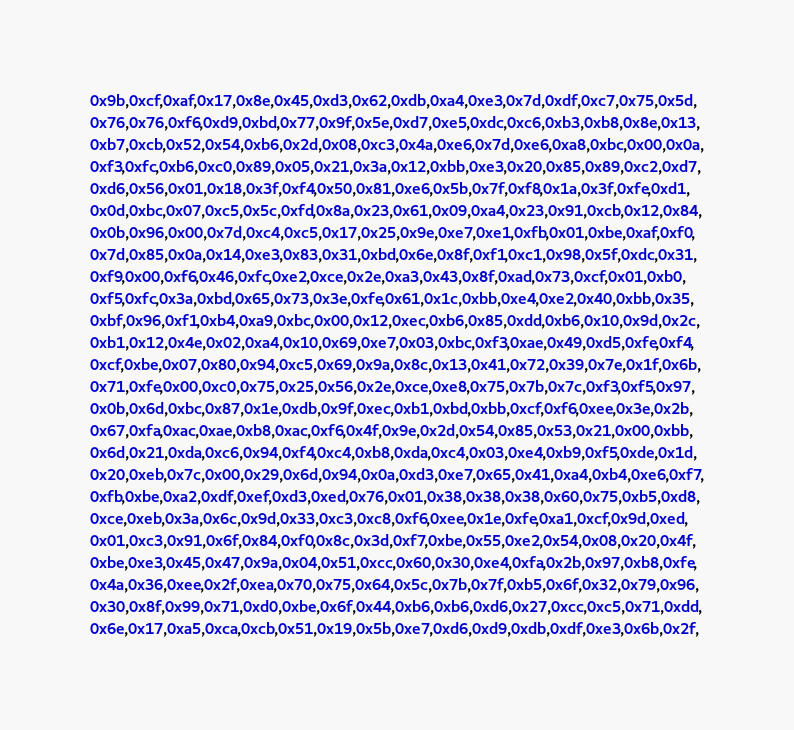<code> <loc_0><loc_0><loc_500><loc_500><_C_>0x9b,0xcf,0xaf,0x17,0x8e,0x45,0xd3,0x62,0xdb,0xa4,0xe3,0x7d,0xdf,0xc7,0x75,0x5d,
0x76,0x76,0xf6,0xd9,0xbd,0x77,0x9f,0x5e,0xd7,0xe5,0xdc,0xc6,0xb3,0xb8,0x8e,0x13,
0xb7,0xcb,0x52,0x54,0xb6,0x2d,0x08,0xc3,0x4a,0xe6,0x7d,0xe6,0xa8,0xbc,0x00,0x0a,
0xf3,0xfc,0xb6,0xc0,0x89,0x05,0x21,0x3a,0x12,0xbb,0xe3,0x20,0x85,0x89,0xc2,0xd7,
0xd6,0x56,0x01,0x18,0x3f,0xf4,0x50,0x81,0xe6,0x5b,0x7f,0xf8,0x1a,0x3f,0xfe,0xd1,
0x0d,0xbc,0x07,0xc5,0x5c,0xfd,0x8a,0x23,0x61,0x09,0xa4,0x23,0x91,0xcb,0x12,0x84,
0x0b,0x96,0x00,0x7d,0xc4,0xc5,0x17,0x25,0x9e,0xe7,0xe1,0xfb,0x01,0xbe,0xaf,0xf0,
0x7d,0x85,0x0a,0x14,0xe3,0x83,0x31,0xbd,0x6e,0x8f,0xf1,0xc1,0x98,0x5f,0xdc,0x31,
0xf9,0x00,0xf6,0x46,0xfc,0xe2,0xce,0x2e,0xa3,0x43,0x8f,0xad,0x73,0xcf,0x01,0xb0,
0xf5,0xfc,0x3a,0xbd,0x65,0x73,0x3e,0xfe,0x61,0x1c,0xbb,0xe4,0xe2,0x40,0xbb,0x35,
0xbf,0x96,0xf1,0xb4,0xa9,0xbc,0x00,0x12,0xec,0xb6,0x85,0xdd,0xb6,0x10,0x9d,0x2c,
0xb1,0x12,0x4e,0x02,0xa4,0x10,0x69,0xe7,0x03,0xbc,0xf3,0xae,0x49,0xd5,0xfe,0xf4,
0xcf,0xbe,0x07,0x80,0x94,0xc5,0x69,0x9a,0x8c,0x13,0x41,0x72,0x39,0x7e,0x1f,0x6b,
0x71,0xfe,0x00,0xc0,0x75,0x25,0x56,0x2e,0xce,0xe8,0x75,0x7b,0x7c,0xf3,0xf5,0x97,
0x0b,0x6d,0xbc,0x87,0x1e,0xdb,0x9f,0xec,0xb1,0xbd,0xbb,0xcf,0xf6,0xee,0x3e,0x2b,
0x67,0xfa,0xac,0xae,0xb8,0xac,0xf6,0x4f,0x9e,0x2d,0x54,0x85,0x53,0x21,0x00,0xbb,
0x6d,0x21,0xda,0xc6,0x94,0xf4,0xc4,0xb8,0xda,0xc4,0x03,0xe4,0xb9,0xf5,0xde,0x1d,
0x20,0xeb,0x7c,0x00,0x29,0x6d,0x94,0x0a,0xd3,0xe7,0x65,0x41,0xa4,0xb4,0xe6,0xf7,
0xfb,0xbe,0xa2,0xdf,0xef,0xd3,0xed,0x76,0x01,0x38,0x38,0x38,0x60,0x75,0xb5,0xd8,
0xce,0xeb,0x3a,0x6c,0x9d,0x33,0xc3,0xc8,0xf6,0xee,0x1e,0xfe,0xa1,0xcf,0x9d,0xed,
0x01,0xc3,0x91,0x6f,0x84,0xf0,0x8c,0x3d,0xf7,0xbe,0x55,0xe2,0x54,0x08,0x20,0x4f,
0xbe,0xe3,0x45,0x47,0x9a,0x04,0x51,0xcc,0x60,0x30,0xe4,0xfa,0x2b,0x97,0xb8,0xfe,
0x4a,0x36,0xee,0x2f,0xea,0x70,0x75,0x64,0x5c,0x7b,0x7f,0xb5,0x6f,0x32,0x79,0x96,
0x30,0x8f,0x99,0x71,0xd0,0xbe,0x6f,0x44,0xb6,0xb6,0xd6,0x27,0xcc,0xc5,0x71,0xdd,
0x6e,0x17,0xa5,0xca,0xcb,0x51,0x19,0x5b,0xe7,0xd6,0xd9,0xdb,0xdf,0xe3,0x6b,0x2f,</code> 